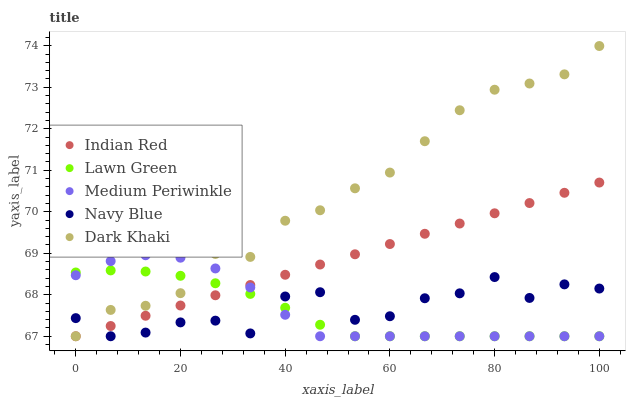Does Lawn Green have the minimum area under the curve?
Answer yes or no. Yes. Does Dark Khaki have the maximum area under the curve?
Answer yes or no. Yes. Does Medium Periwinkle have the minimum area under the curve?
Answer yes or no. No. Does Medium Periwinkle have the maximum area under the curve?
Answer yes or no. No. Is Indian Red the smoothest?
Answer yes or no. Yes. Is Navy Blue the roughest?
Answer yes or no. Yes. Is Lawn Green the smoothest?
Answer yes or no. No. Is Lawn Green the roughest?
Answer yes or no. No. Does Dark Khaki have the lowest value?
Answer yes or no. Yes. Does Dark Khaki have the highest value?
Answer yes or no. Yes. Does Lawn Green have the highest value?
Answer yes or no. No. Does Medium Periwinkle intersect Indian Red?
Answer yes or no. Yes. Is Medium Periwinkle less than Indian Red?
Answer yes or no. No. Is Medium Periwinkle greater than Indian Red?
Answer yes or no. No. 